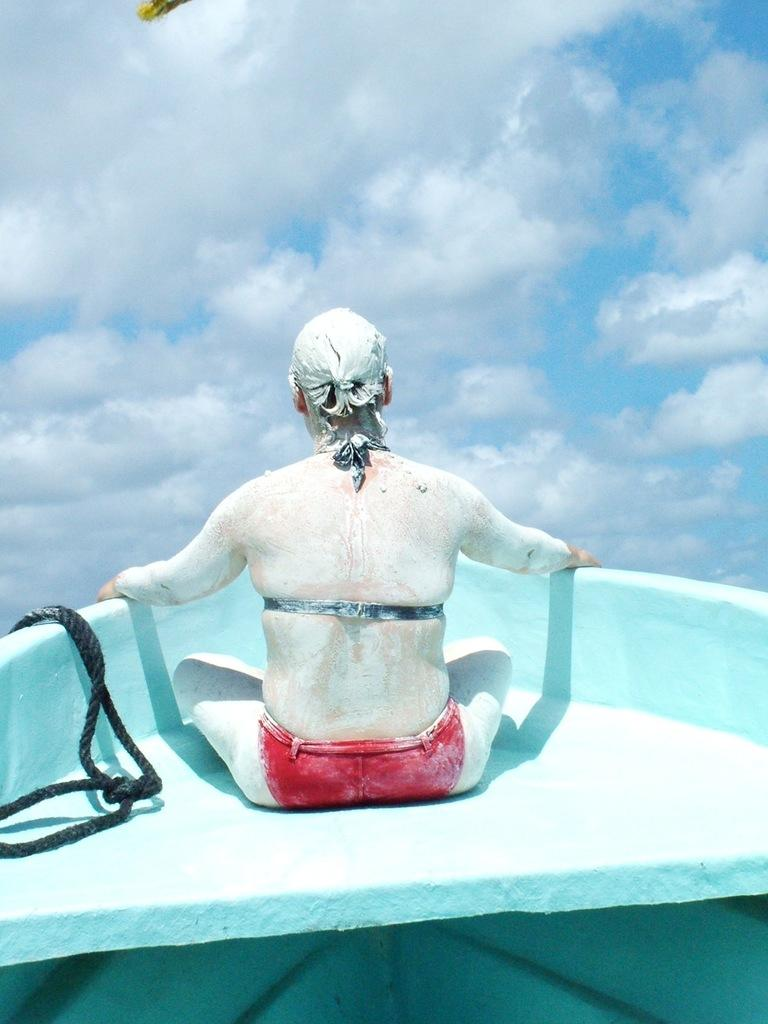What is the person in the image doing? The person is sitting on a boat in the image. What is the person holding while sitting on the boat? The person is holding a rope. How is the person's body decorated in the image? The person has painted their body. What is visible at the top of the image? The sky is visible at the top of the image. What can be seen in the sky in the image? There are clouds in the sky. What type of silk is being used to cover the base in the image? There is no silk or base present in the image; it features a person sitting on a boat with a rope and painted body. 